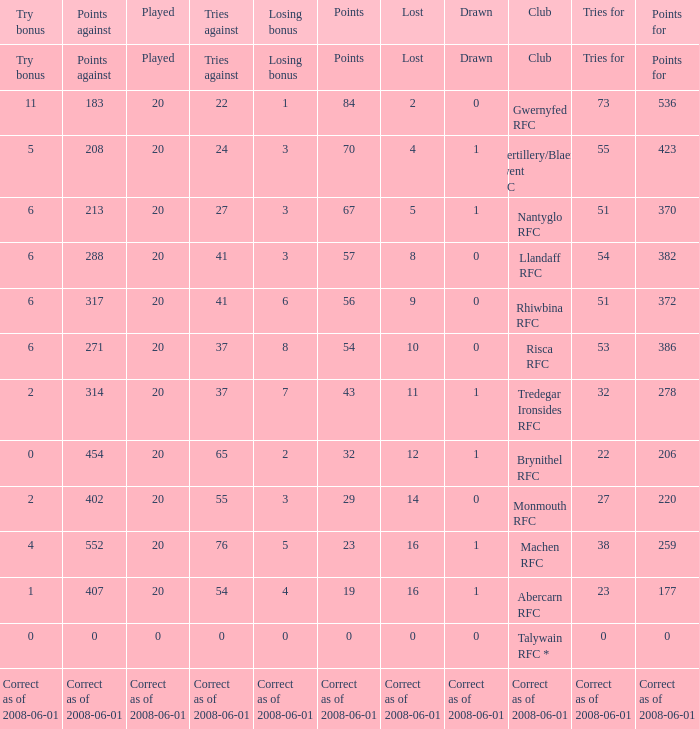Name the tries when tries against were 41, try bonus was 6, and had 317 points. 51.0. 